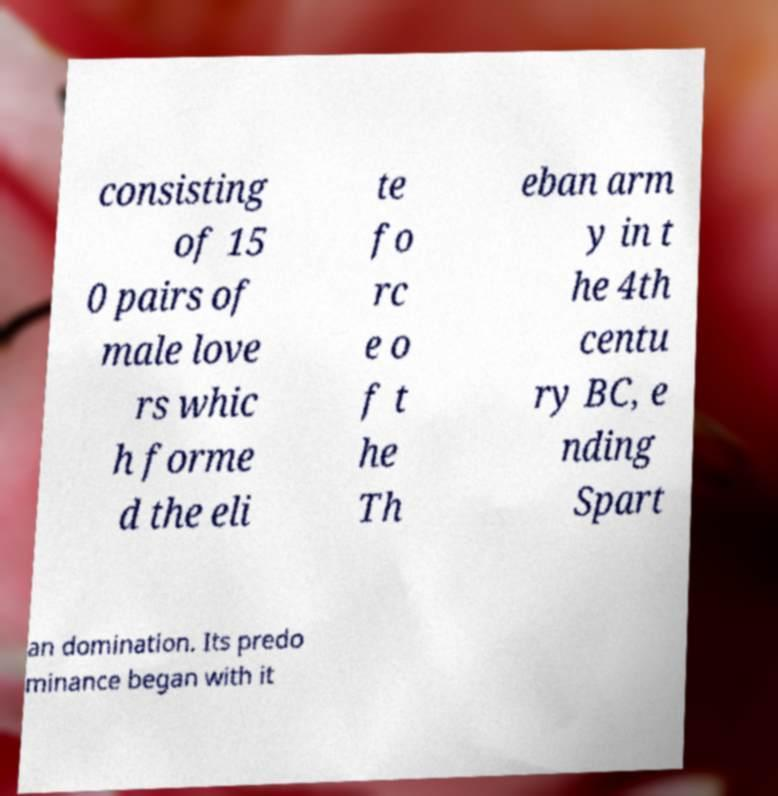Could you extract and type out the text from this image? consisting of 15 0 pairs of male love rs whic h forme d the eli te fo rc e o f t he Th eban arm y in t he 4th centu ry BC, e nding Spart an domination. Its predo minance began with it 